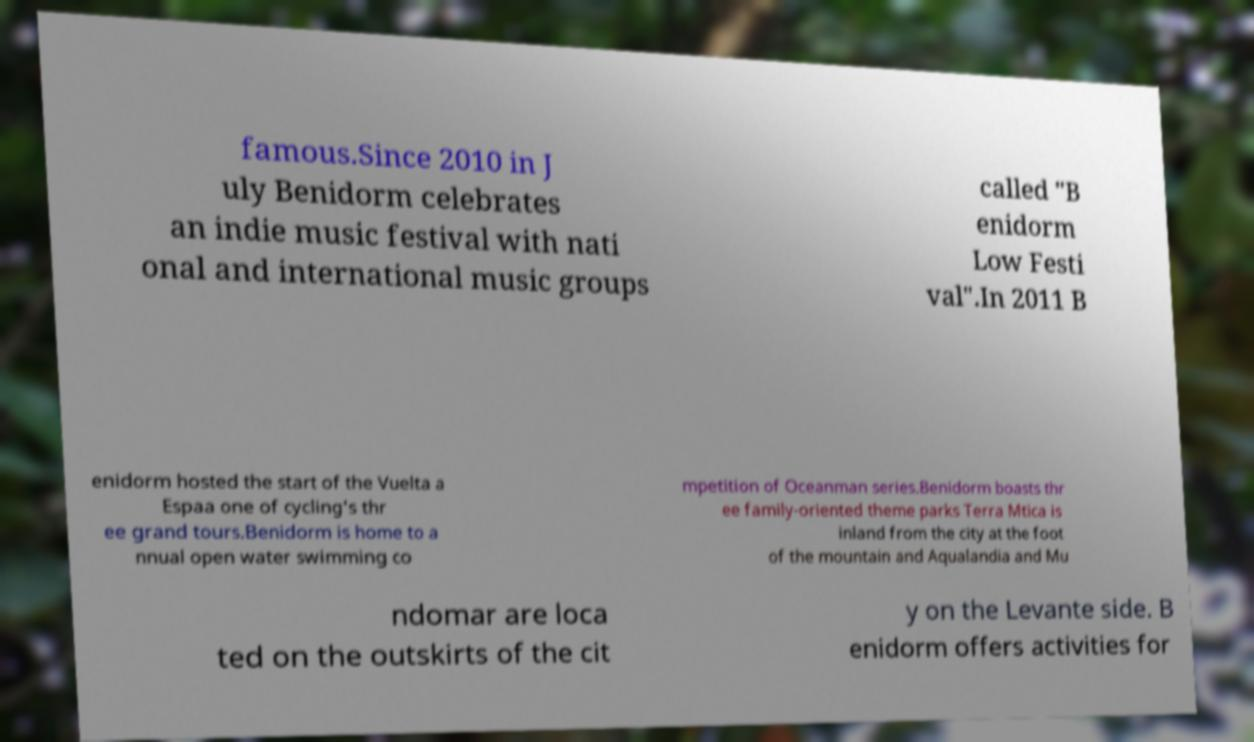Could you extract and type out the text from this image? famous.Since 2010 in J uly Benidorm celebrates an indie music festival with nati onal and international music groups called "B enidorm Low Festi val".In 2011 B enidorm hosted the start of the Vuelta a Espaa one of cycling's thr ee grand tours.Benidorm is home to a nnual open water swimming co mpetition of Oceanman series.Benidorm boasts thr ee family-oriented theme parks Terra Mtica is inland from the city at the foot of the mountain and Aqualandia and Mu ndomar are loca ted on the outskirts of the cit y on the Levante side. B enidorm offers activities for 